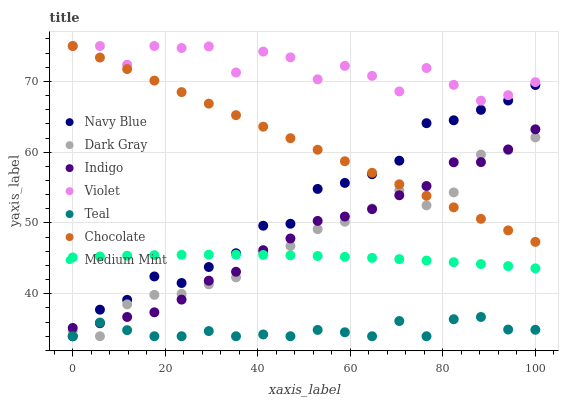Does Teal have the minimum area under the curve?
Answer yes or no. Yes. Does Violet have the maximum area under the curve?
Answer yes or no. Yes. Does Indigo have the minimum area under the curve?
Answer yes or no. No. Does Indigo have the maximum area under the curve?
Answer yes or no. No. Is Chocolate the smoothest?
Answer yes or no. Yes. Is Violet the roughest?
Answer yes or no. Yes. Is Indigo the smoothest?
Answer yes or no. No. Is Indigo the roughest?
Answer yes or no. No. Does Navy Blue have the lowest value?
Answer yes or no. Yes. Does Indigo have the lowest value?
Answer yes or no. No. Does Violet have the highest value?
Answer yes or no. Yes. Does Indigo have the highest value?
Answer yes or no. No. Is Teal less than Chocolate?
Answer yes or no. Yes. Is Violet greater than Teal?
Answer yes or no. Yes. Does Teal intersect Navy Blue?
Answer yes or no. Yes. Is Teal less than Navy Blue?
Answer yes or no. No. Is Teal greater than Navy Blue?
Answer yes or no. No. Does Teal intersect Chocolate?
Answer yes or no. No. 